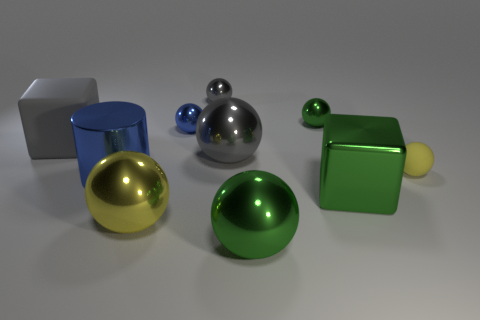Subtract all small rubber balls. How many balls are left? 6 Subtract 6 balls. How many balls are left? 1 Subtract all brown spheres. Subtract all green cylinders. How many spheres are left? 7 Subtract all gray spheres. How many purple cylinders are left? 0 Subtract all big green metallic balls. Subtract all tiny gray shiny balls. How many objects are left? 8 Add 2 metal cylinders. How many metal cylinders are left? 3 Add 2 blue balls. How many blue balls exist? 3 Subtract all green cubes. How many cubes are left? 1 Subtract 0 brown blocks. How many objects are left? 10 Subtract all cubes. How many objects are left? 8 